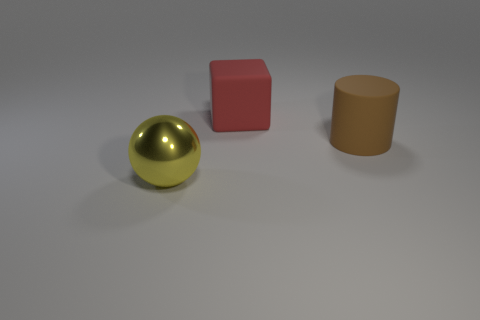What number of large things have the same material as the brown cylinder?
Provide a succinct answer. 1. What number of other objects are the same size as the brown matte thing?
Your answer should be very brief. 2. Is there a red cube of the same size as the ball?
Your answer should be compact. Yes. There is a large rubber block left of the brown matte cylinder; is its color the same as the large cylinder?
Provide a short and direct response. No. How many things are either big brown cylinders or small gray metal objects?
Give a very brief answer. 1. There is a rubber thing in front of the rubber block; does it have the same size as the large red cube?
Ensure brevity in your answer.  Yes. What size is the object that is both to the left of the large cylinder and in front of the matte block?
Your answer should be very brief. Large. What number of other things are there of the same shape as the metallic thing?
Make the answer very short. 0. What number of other objects are the same material as the brown object?
Your answer should be very brief. 1. Do the cylinder and the big block have the same color?
Your response must be concise. No. 